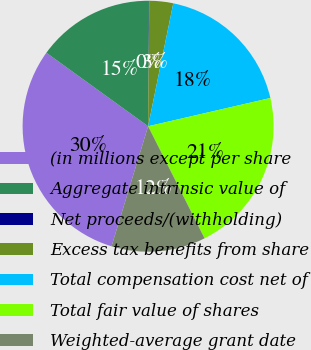Convert chart. <chart><loc_0><loc_0><loc_500><loc_500><pie_chart><fcel>(in millions except per share<fcel>Aggregate intrinsic value of<fcel>Net proceeds/(withholding)<fcel>Excess tax benefits from share<fcel>Total compensation cost net of<fcel>Total fair value of shares<fcel>Weighted-average grant date<nl><fcel>30.25%<fcel>15.15%<fcel>0.04%<fcel>3.07%<fcel>18.17%<fcel>21.19%<fcel>12.13%<nl></chart> 